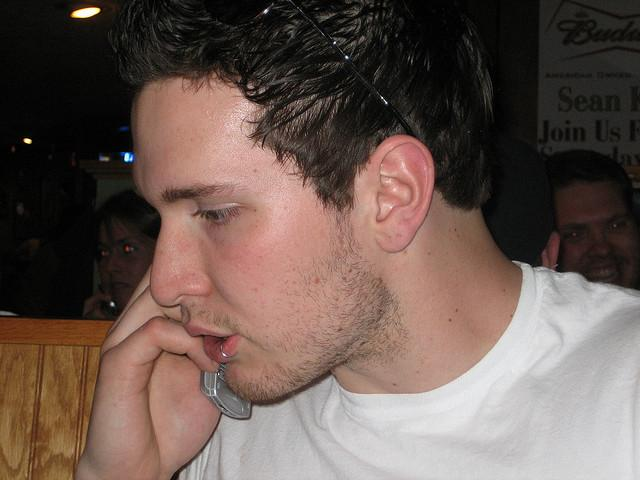What color is the cell phone which the man talks on?

Choices:
A) pink
B) white
C) black
D) gray gray 